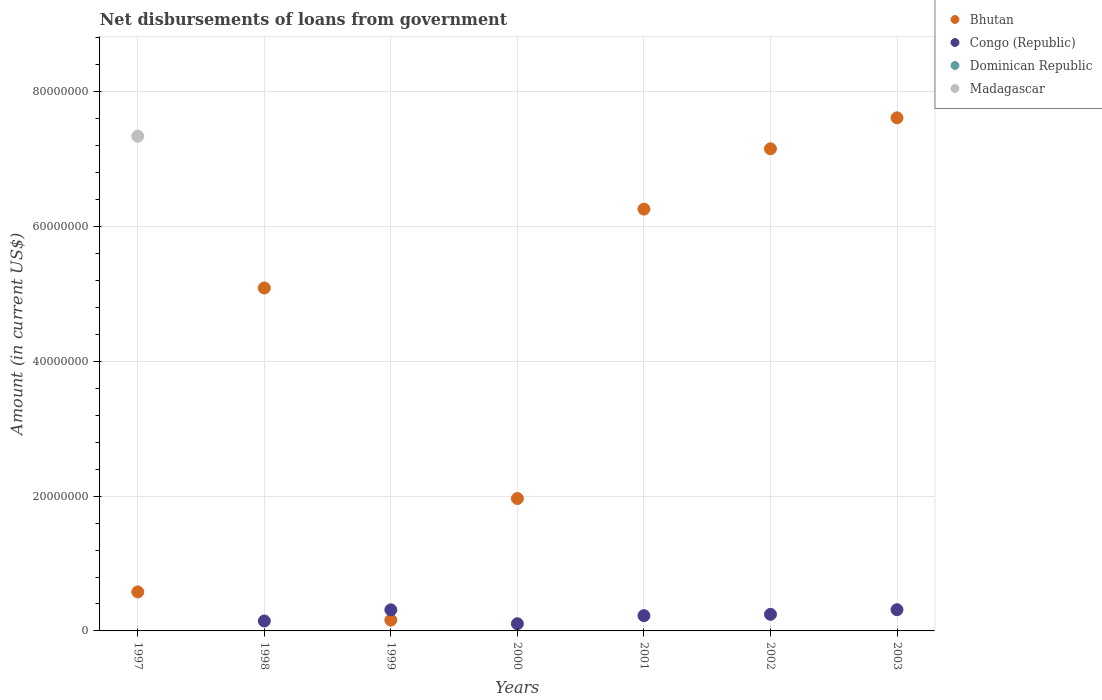How many different coloured dotlines are there?
Your response must be concise. 3. Is the number of dotlines equal to the number of legend labels?
Offer a terse response. No. What is the amount of loan disbursed from government in Madagascar in 1999?
Your response must be concise. 0. Across all years, what is the maximum amount of loan disbursed from government in Congo (Republic)?
Ensure brevity in your answer.  3.15e+06. What is the total amount of loan disbursed from government in Bhutan in the graph?
Provide a succinct answer. 2.88e+08. What is the difference between the amount of loan disbursed from government in Congo (Republic) in 1999 and that in 2001?
Offer a terse response. 8.61e+05. What is the difference between the amount of loan disbursed from government in Congo (Republic) in 1998 and the amount of loan disbursed from government in Dominican Republic in 1997?
Offer a very short reply. 1.47e+06. What is the average amount of loan disbursed from government in Madagascar per year?
Give a very brief answer. 1.05e+07. In the year 2003, what is the difference between the amount of loan disbursed from government in Congo (Republic) and amount of loan disbursed from government in Bhutan?
Your answer should be compact. -7.30e+07. What is the ratio of the amount of loan disbursed from government in Bhutan in 1997 to that in 2000?
Offer a terse response. 0.29. Is the amount of loan disbursed from government in Bhutan in 2000 less than that in 2001?
Provide a short and direct response. Yes. Is the difference between the amount of loan disbursed from government in Congo (Republic) in 1999 and 2003 greater than the difference between the amount of loan disbursed from government in Bhutan in 1999 and 2003?
Your answer should be very brief. Yes. What is the difference between the highest and the second highest amount of loan disbursed from government in Congo (Republic)?
Offer a very short reply. 2.00e+04. What is the difference between the highest and the lowest amount of loan disbursed from government in Madagascar?
Provide a short and direct response. 7.34e+07. In how many years, is the amount of loan disbursed from government in Madagascar greater than the average amount of loan disbursed from government in Madagascar taken over all years?
Your answer should be very brief. 1. Is it the case that in every year, the sum of the amount of loan disbursed from government in Congo (Republic) and amount of loan disbursed from government in Madagascar  is greater than the sum of amount of loan disbursed from government in Dominican Republic and amount of loan disbursed from government in Bhutan?
Give a very brief answer. No. Is it the case that in every year, the sum of the amount of loan disbursed from government in Madagascar and amount of loan disbursed from government in Bhutan  is greater than the amount of loan disbursed from government in Dominican Republic?
Your response must be concise. Yes. What is the difference between two consecutive major ticks on the Y-axis?
Your answer should be very brief. 2.00e+07. Are the values on the major ticks of Y-axis written in scientific E-notation?
Offer a very short reply. No. Where does the legend appear in the graph?
Provide a short and direct response. Top right. How are the legend labels stacked?
Ensure brevity in your answer.  Vertical. What is the title of the graph?
Make the answer very short. Net disbursements of loans from government. Does "Korea (Republic)" appear as one of the legend labels in the graph?
Offer a very short reply. No. What is the label or title of the X-axis?
Keep it short and to the point. Years. What is the label or title of the Y-axis?
Offer a terse response. Amount (in current US$). What is the Amount (in current US$) in Bhutan in 1997?
Provide a short and direct response. 5.79e+06. What is the Amount (in current US$) in Madagascar in 1997?
Provide a succinct answer. 7.34e+07. What is the Amount (in current US$) of Bhutan in 1998?
Your answer should be very brief. 5.09e+07. What is the Amount (in current US$) in Congo (Republic) in 1998?
Your answer should be very brief. 1.47e+06. What is the Amount (in current US$) of Dominican Republic in 1998?
Offer a terse response. 0. What is the Amount (in current US$) in Bhutan in 1999?
Offer a terse response. 1.60e+06. What is the Amount (in current US$) in Congo (Republic) in 1999?
Offer a very short reply. 3.13e+06. What is the Amount (in current US$) of Dominican Republic in 1999?
Give a very brief answer. 0. What is the Amount (in current US$) in Madagascar in 1999?
Keep it short and to the point. 0. What is the Amount (in current US$) in Bhutan in 2000?
Provide a short and direct response. 1.96e+07. What is the Amount (in current US$) of Congo (Republic) in 2000?
Your answer should be compact. 1.07e+06. What is the Amount (in current US$) in Dominican Republic in 2000?
Give a very brief answer. 0. What is the Amount (in current US$) in Bhutan in 2001?
Ensure brevity in your answer.  6.26e+07. What is the Amount (in current US$) in Congo (Republic) in 2001?
Make the answer very short. 2.27e+06. What is the Amount (in current US$) in Dominican Republic in 2001?
Your answer should be very brief. 0. What is the Amount (in current US$) of Madagascar in 2001?
Your answer should be very brief. 0. What is the Amount (in current US$) in Bhutan in 2002?
Ensure brevity in your answer.  7.15e+07. What is the Amount (in current US$) in Congo (Republic) in 2002?
Ensure brevity in your answer.  2.46e+06. What is the Amount (in current US$) in Bhutan in 2003?
Keep it short and to the point. 7.61e+07. What is the Amount (in current US$) of Congo (Republic) in 2003?
Offer a terse response. 3.15e+06. Across all years, what is the maximum Amount (in current US$) of Bhutan?
Offer a terse response. 7.61e+07. Across all years, what is the maximum Amount (in current US$) of Congo (Republic)?
Provide a succinct answer. 3.15e+06. Across all years, what is the maximum Amount (in current US$) in Madagascar?
Your answer should be compact. 7.34e+07. Across all years, what is the minimum Amount (in current US$) in Bhutan?
Your answer should be compact. 1.60e+06. What is the total Amount (in current US$) in Bhutan in the graph?
Your answer should be compact. 2.88e+08. What is the total Amount (in current US$) in Congo (Republic) in the graph?
Ensure brevity in your answer.  1.35e+07. What is the total Amount (in current US$) of Dominican Republic in the graph?
Give a very brief answer. 0. What is the total Amount (in current US$) in Madagascar in the graph?
Give a very brief answer. 7.34e+07. What is the difference between the Amount (in current US$) of Bhutan in 1997 and that in 1998?
Give a very brief answer. -4.51e+07. What is the difference between the Amount (in current US$) of Bhutan in 1997 and that in 1999?
Your response must be concise. 4.18e+06. What is the difference between the Amount (in current US$) of Bhutan in 1997 and that in 2000?
Your answer should be very brief. -1.39e+07. What is the difference between the Amount (in current US$) in Bhutan in 1997 and that in 2001?
Ensure brevity in your answer.  -5.68e+07. What is the difference between the Amount (in current US$) in Bhutan in 1997 and that in 2002?
Offer a very short reply. -6.57e+07. What is the difference between the Amount (in current US$) in Bhutan in 1997 and that in 2003?
Offer a terse response. -7.03e+07. What is the difference between the Amount (in current US$) of Bhutan in 1998 and that in 1999?
Make the answer very short. 4.93e+07. What is the difference between the Amount (in current US$) in Congo (Republic) in 1998 and that in 1999?
Provide a short and direct response. -1.66e+06. What is the difference between the Amount (in current US$) in Bhutan in 1998 and that in 2000?
Offer a very short reply. 3.12e+07. What is the difference between the Amount (in current US$) of Congo (Republic) in 1998 and that in 2000?
Offer a very short reply. 4.05e+05. What is the difference between the Amount (in current US$) in Bhutan in 1998 and that in 2001?
Provide a short and direct response. -1.17e+07. What is the difference between the Amount (in current US$) in Congo (Republic) in 1998 and that in 2001?
Keep it short and to the point. -7.95e+05. What is the difference between the Amount (in current US$) in Bhutan in 1998 and that in 2002?
Ensure brevity in your answer.  -2.06e+07. What is the difference between the Amount (in current US$) in Congo (Republic) in 1998 and that in 2002?
Offer a terse response. -9.88e+05. What is the difference between the Amount (in current US$) in Bhutan in 1998 and that in 2003?
Give a very brief answer. -2.52e+07. What is the difference between the Amount (in current US$) of Congo (Republic) in 1998 and that in 2003?
Make the answer very short. -1.68e+06. What is the difference between the Amount (in current US$) of Bhutan in 1999 and that in 2000?
Your response must be concise. -1.80e+07. What is the difference between the Amount (in current US$) of Congo (Republic) in 1999 and that in 2000?
Your response must be concise. 2.06e+06. What is the difference between the Amount (in current US$) of Bhutan in 1999 and that in 2001?
Provide a short and direct response. -6.10e+07. What is the difference between the Amount (in current US$) in Congo (Republic) in 1999 and that in 2001?
Keep it short and to the point. 8.61e+05. What is the difference between the Amount (in current US$) of Bhutan in 1999 and that in 2002?
Your answer should be very brief. -6.99e+07. What is the difference between the Amount (in current US$) of Congo (Republic) in 1999 and that in 2002?
Your answer should be compact. 6.68e+05. What is the difference between the Amount (in current US$) in Bhutan in 1999 and that in 2003?
Provide a succinct answer. -7.45e+07. What is the difference between the Amount (in current US$) of Bhutan in 2000 and that in 2001?
Provide a succinct answer. -4.29e+07. What is the difference between the Amount (in current US$) of Congo (Republic) in 2000 and that in 2001?
Ensure brevity in your answer.  -1.20e+06. What is the difference between the Amount (in current US$) in Bhutan in 2000 and that in 2002?
Your answer should be very brief. -5.19e+07. What is the difference between the Amount (in current US$) of Congo (Republic) in 2000 and that in 2002?
Offer a very short reply. -1.39e+06. What is the difference between the Amount (in current US$) in Bhutan in 2000 and that in 2003?
Your answer should be very brief. -5.65e+07. What is the difference between the Amount (in current US$) of Congo (Republic) in 2000 and that in 2003?
Ensure brevity in your answer.  -2.08e+06. What is the difference between the Amount (in current US$) in Bhutan in 2001 and that in 2002?
Your answer should be compact. -8.95e+06. What is the difference between the Amount (in current US$) in Congo (Republic) in 2001 and that in 2002?
Offer a very short reply. -1.93e+05. What is the difference between the Amount (in current US$) in Bhutan in 2001 and that in 2003?
Ensure brevity in your answer.  -1.35e+07. What is the difference between the Amount (in current US$) in Congo (Republic) in 2001 and that in 2003?
Offer a terse response. -8.81e+05. What is the difference between the Amount (in current US$) in Bhutan in 2002 and that in 2003?
Keep it short and to the point. -4.60e+06. What is the difference between the Amount (in current US$) of Congo (Republic) in 2002 and that in 2003?
Give a very brief answer. -6.88e+05. What is the difference between the Amount (in current US$) in Bhutan in 1997 and the Amount (in current US$) in Congo (Republic) in 1998?
Provide a succinct answer. 4.32e+06. What is the difference between the Amount (in current US$) of Bhutan in 1997 and the Amount (in current US$) of Congo (Republic) in 1999?
Keep it short and to the point. 2.66e+06. What is the difference between the Amount (in current US$) of Bhutan in 1997 and the Amount (in current US$) of Congo (Republic) in 2000?
Provide a succinct answer. 4.72e+06. What is the difference between the Amount (in current US$) in Bhutan in 1997 and the Amount (in current US$) in Congo (Republic) in 2001?
Ensure brevity in your answer.  3.52e+06. What is the difference between the Amount (in current US$) in Bhutan in 1997 and the Amount (in current US$) in Congo (Republic) in 2002?
Provide a succinct answer. 3.33e+06. What is the difference between the Amount (in current US$) of Bhutan in 1997 and the Amount (in current US$) of Congo (Republic) in 2003?
Give a very brief answer. 2.64e+06. What is the difference between the Amount (in current US$) of Bhutan in 1998 and the Amount (in current US$) of Congo (Republic) in 1999?
Provide a succinct answer. 4.78e+07. What is the difference between the Amount (in current US$) of Bhutan in 1998 and the Amount (in current US$) of Congo (Republic) in 2000?
Offer a very short reply. 4.98e+07. What is the difference between the Amount (in current US$) of Bhutan in 1998 and the Amount (in current US$) of Congo (Republic) in 2001?
Offer a very short reply. 4.86e+07. What is the difference between the Amount (in current US$) in Bhutan in 1998 and the Amount (in current US$) in Congo (Republic) in 2002?
Keep it short and to the point. 4.84e+07. What is the difference between the Amount (in current US$) of Bhutan in 1998 and the Amount (in current US$) of Congo (Republic) in 2003?
Provide a short and direct response. 4.77e+07. What is the difference between the Amount (in current US$) of Bhutan in 1999 and the Amount (in current US$) of Congo (Republic) in 2000?
Your response must be concise. 5.37e+05. What is the difference between the Amount (in current US$) in Bhutan in 1999 and the Amount (in current US$) in Congo (Republic) in 2001?
Your answer should be compact. -6.63e+05. What is the difference between the Amount (in current US$) of Bhutan in 1999 and the Amount (in current US$) of Congo (Republic) in 2002?
Give a very brief answer. -8.56e+05. What is the difference between the Amount (in current US$) in Bhutan in 1999 and the Amount (in current US$) in Congo (Republic) in 2003?
Provide a succinct answer. -1.54e+06. What is the difference between the Amount (in current US$) of Bhutan in 2000 and the Amount (in current US$) of Congo (Republic) in 2001?
Give a very brief answer. 1.74e+07. What is the difference between the Amount (in current US$) in Bhutan in 2000 and the Amount (in current US$) in Congo (Republic) in 2002?
Offer a very short reply. 1.72e+07. What is the difference between the Amount (in current US$) in Bhutan in 2000 and the Amount (in current US$) in Congo (Republic) in 2003?
Ensure brevity in your answer.  1.65e+07. What is the difference between the Amount (in current US$) in Bhutan in 2001 and the Amount (in current US$) in Congo (Republic) in 2002?
Give a very brief answer. 6.01e+07. What is the difference between the Amount (in current US$) of Bhutan in 2001 and the Amount (in current US$) of Congo (Republic) in 2003?
Give a very brief answer. 5.94e+07. What is the difference between the Amount (in current US$) in Bhutan in 2002 and the Amount (in current US$) in Congo (Republic) in 2003?
Your response must be concise. 6.84e+07. What is the average Amount (in current US$) in Bhutan per year?
Your answer should be very brief. 4.12e+07. What is the average Amount (in current US$) in Congo (Republic) per year?
Offer a very short reply. 1.94e+06. What is the average Amount (in current US$) of Dominican Republic per year?
Give a very brief answer. 0. What is the average Amount (in current US$) of Madagascar per year?
Offer a terse response. 1.05e+07. In the year 1997, what is the difference between the Amount (in current US$) of Bhutan and Amount (in current US$) of Madagascar?
Your answer should be very brief. -6.76e+07. In the year 1998, what is the difference between the Amount (in current US$) of Bhutan and Amount (in current US$) of Congo (Republic)?
Make the answer very short. 4.94e+07. In the year 1999, what is the difference between the Amount (in current US$) in Bhutan and Amount (in current US$) in Congo (Republic)?
Your response must be concise. -1.52e+06. In the year 2000, what is the difference between the Amount (in current US$) in Bhutan and Amount (in current US$) in Congo (Republic)?
Give a very brief answer. 1.86e+07. In the year 2001, what is the difference between the Amount (in current US$) in Bhutan and Amount (in current US$) in Congo (Republic)?
Give a very brief answer. 6.03e+07. In the year 2002, what is the difference between the Amount (in current US$) of Bhutan and Amount (in current US$) of Congo (Republic)?
Offer a terse response. 6.91e+07. In the year 2003, what is the difference between the Amount (in current US$) in Bhutan and Amount (in current US$) in Congo (Republic)?
Your response must be concise. 7.30e+07. What is the ratio of the Amount (in current US$) in Bhutan in 1997 to that in 1998?
Provide a succinct answer. 0.11. What is the ratio of the Amount (in current US$) in Bhutan in 1997 to that in 1999?
Offer a very short reply. 3.61. What is the ratio of the Amount (in current US$) of Bhutan in 1997 to that in 2000?
Keep it short and to the point. 0.29. What is the ratio of the Amount (in current US$) of Bhutan in 1997 to that in 2001?
Your answer should be compact. 0.09. What is the ratio of the Amount (in current US$) in Bhutan in 1997 to that in 2002?
Provide a succinct answer. 0.08. What is the ratio of the Amount (in current US$) of Bhutan in 1997 to that in 2003?
Ensure brevity in your answer.  0.08. What is the ratio of the Amount (in current US$) in Bhutan in 1998 to that in 1999?
Keep it short and to the point. 31.7. What is the ratio of the Amount (in current US$) in Congo (Republic) in 1998 to that in 1999?
Make the answer very short. 0.47. What is the ratio of the Amount (in current US$) of Bhutan in 1998 to that in 2000?
Provide a short and direct response. 2.59. What is the ratio of the Amount (in current US$) of Congo (Republic) in 1998 to that in 2000?
Your answer should be compact. 1.38. What is the ratio of the Amount (in current US$) of Bhutan in 1998 to that in 2001?
Your answer should be compact. 0.81. What is the ratio of the Amount (in current US$) of Congo (Republic) in 1998 to that in 2001?
Your answer should be very brief. 0.65. What is the ratio of the Amount (in current US$) in Bhutan in 1998 to that in 2002?
Provide a succinct answer. 0.71. What is the ratio of the Amount (in current US$) in Congo (Republic) in 1998 to that in 2002?
Offer a very short reply. 0.6. What is the ratio of the Amount (in current US$) in Bhutan in 1998 to that in 2003?
Your answer should be very brief. 0.67. What is the ratio of the Amount (in current US$) in Congo (Republic) in 1998 to that in 2003?
Your answer should be very brief. 0.47. What is the ratio of the Amount (in current US$) of Bhutan in 1999 to that in 2000?
Offer a very short reply. 0.08. What is the ratio of the Amount (in current US$) in Congo (Republic) in 1999 to that in 2000?
Keep it short and to the point. 2.93. What is the ratio of the Amount (in current US$) of Bhutan in 1999 to that in 2001?
Ensure brevity in your answer.  0.03. What is the ratio of the Amount (in current US$) of Congo (Republic) in 1999 to that in 2001?
Your answer should be compact. 1.38. What is the ratio of the Amount (in current US$) of Bhutan in 1999 to that in 2002?
Provide a succinct answer. 0.02. What is the ratio of the Amount (in current US$) of Congo (Republic) in 1999 to that in 2002?
Provide a short and direct response. 1.27. What is the ratio of the Amount (in current US$) of Bhutan in 1999 to that in 2003?
Offer a terse response. 0.02. What is the ratio of the Amount (in current US$) in Congo (Republic) in 1999 to that in 2003?
Your response must be concise. 0.99. What is the ratio of the Amount (in current US$) of Bhutan in 2000 to that in 2001?
Ensure brevity in your answer.  0.31. What is the ratio of the Amount (in current US$) of Congo (Republic) in 2000 to that in 2001?
Your response must be concise. 0.47. What is the ratio of the Amount (in current US$) of Bhutan in 2000 to that in 2002?
Give a very brief answer. 0.27. What is the ratio of the Amount (in current US$) in Congo (Republic) in 2000 to that in 2002?
Provide a short and direct response. 0.43. What is the ratio of the Amount (in current US$) of Bhutan in 2000 to that in 2003?
Provide a short and direct response. 0.26. What is the ratio of the Amount (in current US$) in Congo (Republic) in 2000 to that in 2003?
Give a very brief answer. 0.34. What is the ratio of the Amount (in current US$) in Bhutan in 2001 to that in 2002?
Give a very brief answer. 0.87. What is the ratio of the Amount (in current US$) in Congo (Republic) in 2001 to that in 2002?
Give a very brief answer. 0.92. What is the ratio of the Amount (in current US$) in Bhutan in 2001 to that in 2003?
Your answer should be compact. 0.82. What is the ratio of the Amount (in current US$) in Congo (Republic) in 2001 to that in 2003?
Your answer should be compact. 0.72. What is the ratio of the Amount (in current US$) of Bhutan in 2002 to that in 2003?
Keep it short and to the point. 0.94. What is the ratio of the Amount (in current US$) of Congo (Republic) in 2002 to that in 2003?
Your response must be concise. 0.78. What is the difference between the highest and the second highest Amount (in current US$) in Bhutan?
Offer a terse response. 4.60e+06. What is the difference between the highest and the lowest Amount (in current US$) in Bhutan?
Your answer should be compact. 7.45e+07. What is the difference between the highest and the lowest Amount (in current US$) in Congo (Republic)?
Offer a terse response. 3.15e+06. What is the difference between the highest and the lowest Amount (in current US$) in Madagascar?
Give a very brief answer. 7.34e+07. 